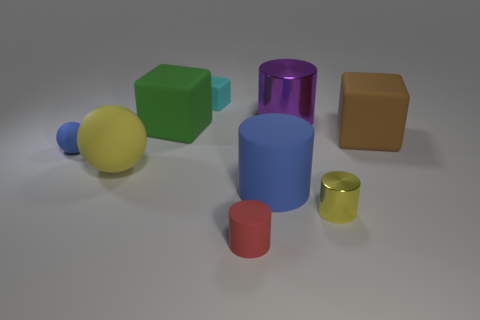Is the shape of the large purple metallic object the same as the green object?
Your response must be concise. No. There is a big blue thing that is the same material as the large brown cube; what is its shape?
Offer a very short reply. Cylinder. What number of small things are either purple metallic objects or red objects?
Keep it short and to the point. 1. Is there a tiny cyan matte thing in front of the large matte block that is to the right of the tiny yellow shiny cylinder?
Give a very brief answer. No. Are any large brown shiny cylinders visible?
Give a very brief answer. No. There is a shiny thing behind the yellow thing to the left of the purple thing; what color is it?
Keep it short and to the point. Purple. What is the material of the tiny red object that is the same shape as the big blue thing?
Make the answer very short. Rubber. What number of other blocks have the same size as the green matte cube?
Your answer should be very brief. 1. What size is the yellow object that is made of the same material as the big brown thing?
Your response must be concise. Large. How many big yellow objects have the same shape as the large blue thing?
Provide a succinct answer. 0. 